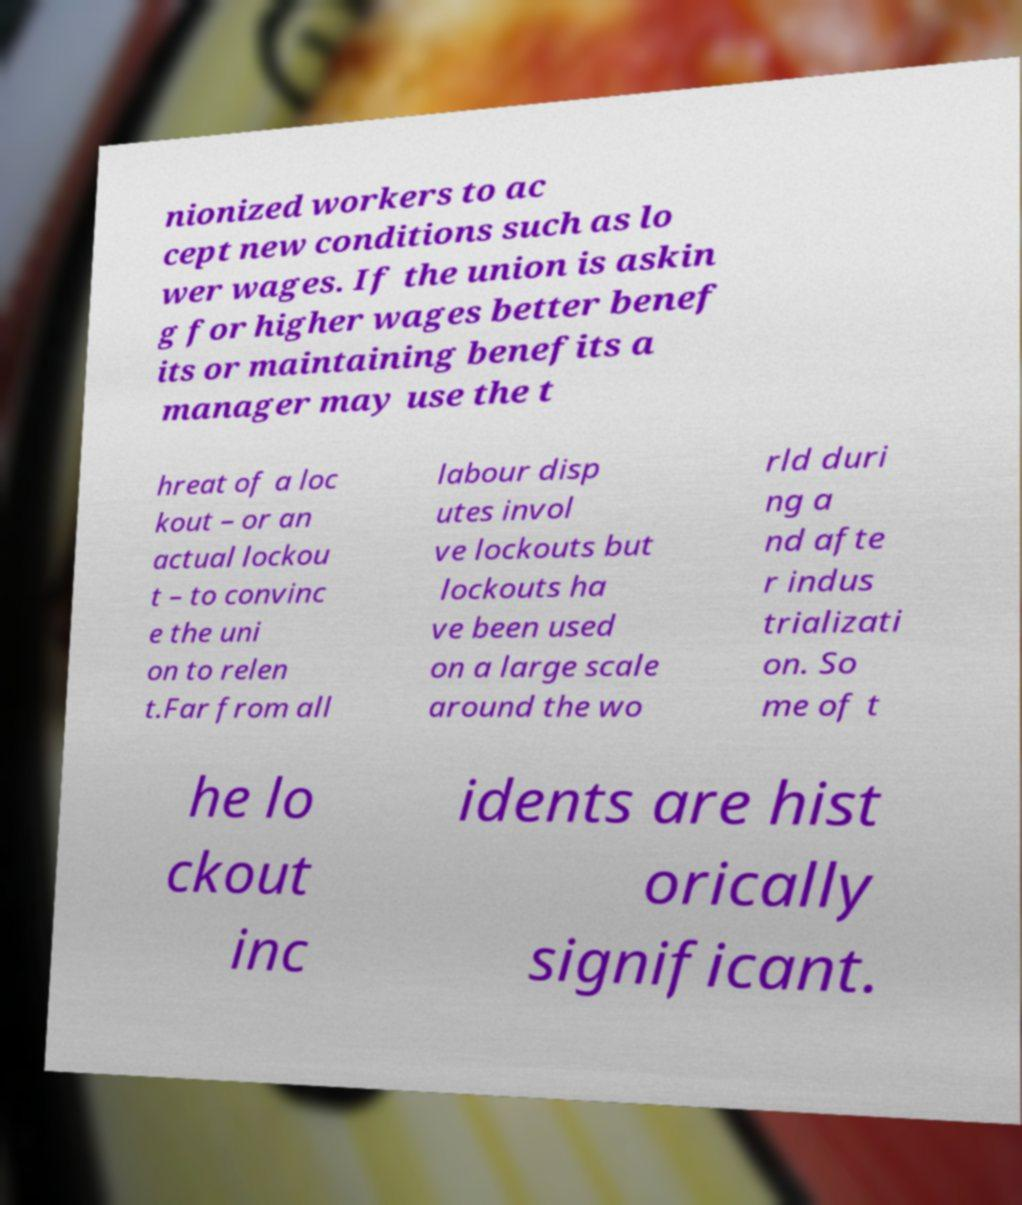Please read and relay the text visible in this image. What does it say? nionized workers to ac cept new conditions such as lo wer wages. If the union is askin g for higher wages better benef its or maintaining benefits a manager may use the t hreat of a loc kout – or an actual lockou t – to convinc e the uni on to relen t.Far from all labour disp utes invol ve lockouts but lockouts ha ve been used on a large scale around the wo rld duri ng a nd afte r indus trializati on. So me of t he lo ckout inc idents are hist orically significant. 